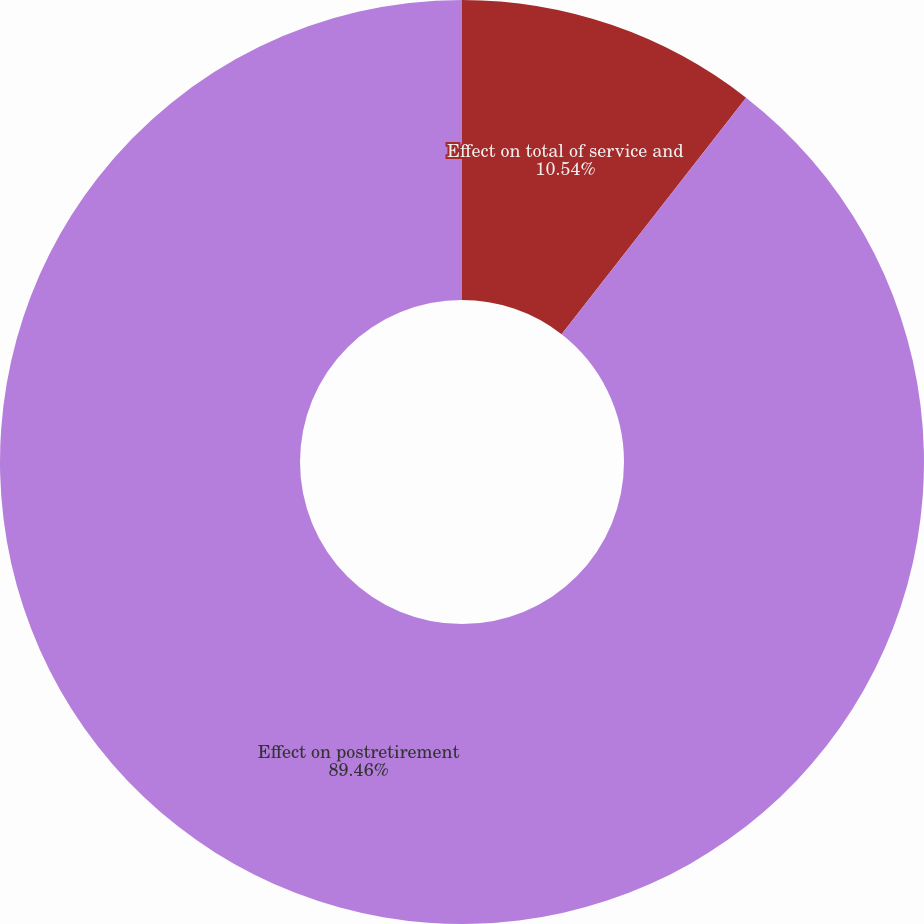Convert chart. <chart><loc_0><loc_0><loc_500><loc_500><pie_chart><fcel>Effect on total of service and<fcel>Effect on postretirement<nl><fcel>10.54%<fcel>89.46%<nl></chart> 